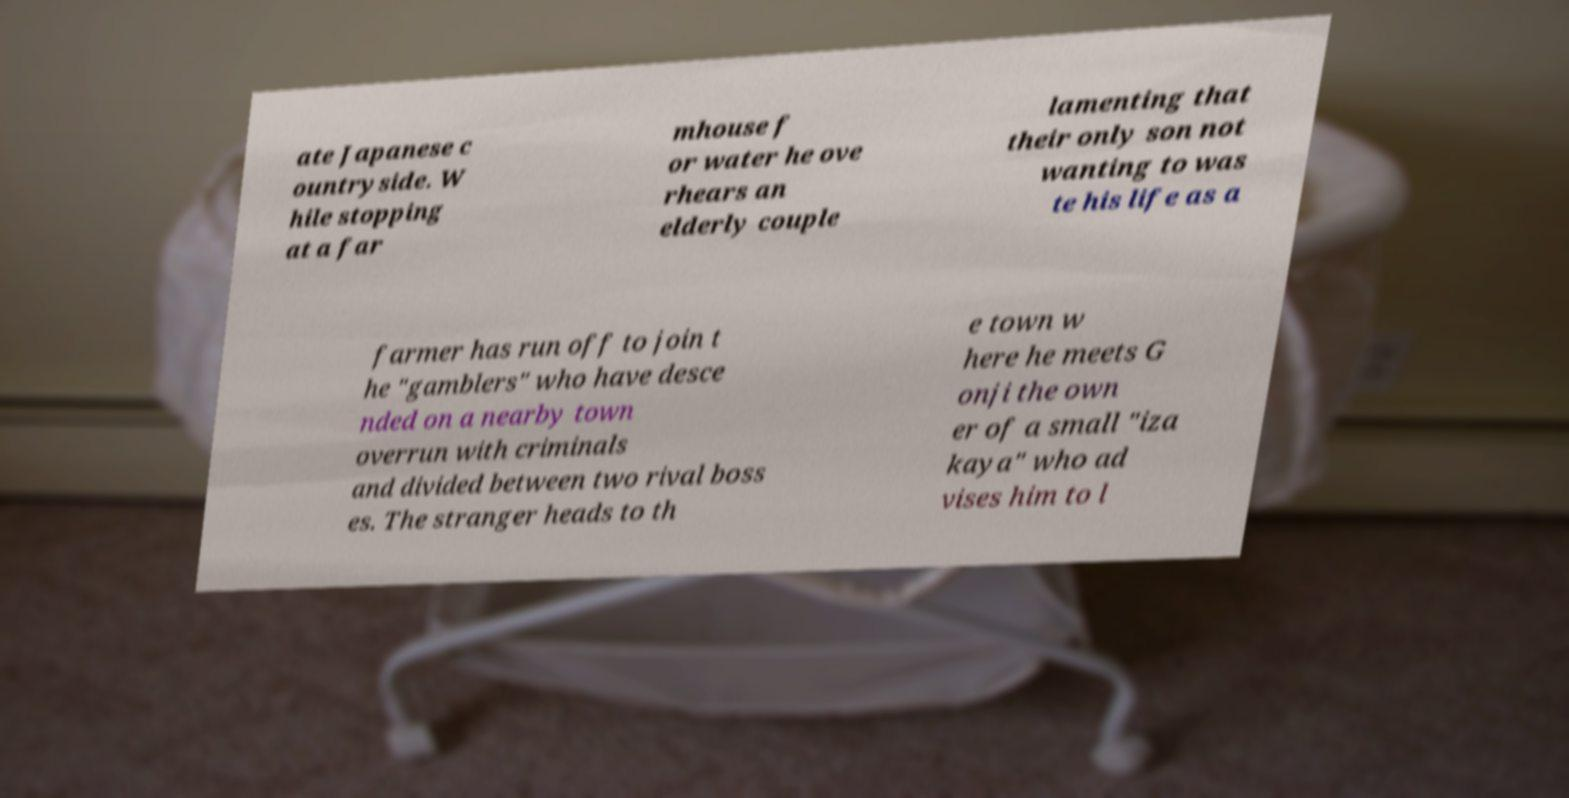Could you assist in decoding the text presented in this image and type it out clearly? ate Japanese c ountryside. W hile stopping at a far mhouse f or water he ove rhears an elderly couple lamenting that their only son not wanting to was te his life as a farmer has run off to join t he "gamblers" who have desce nded on a nearby town overrun with criminals and divided between two rival boss es. The stranger heads to th e town w here he meets G onji the own er of a small "iza kaya" who ad vises him to l 